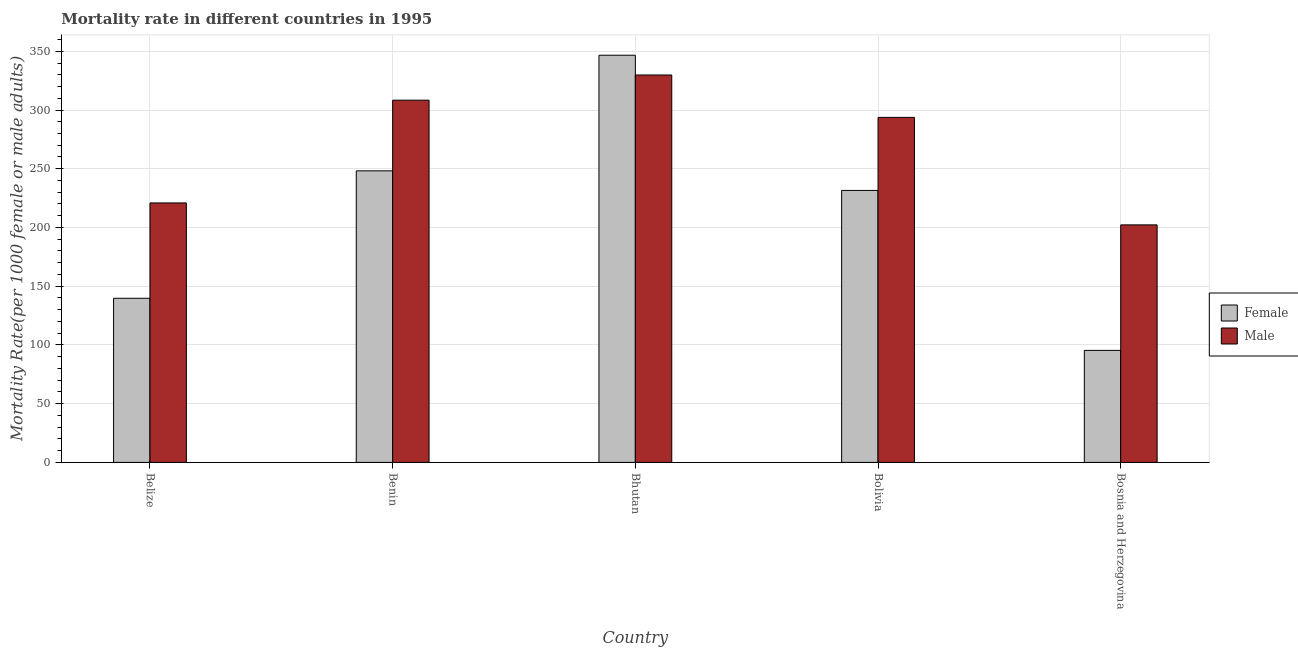How many different coloured bars are there?
Your answer should be compact. 2. Are the number of bars per tick equal to the number of legend labels?
Provide a succinct answer. Yes. Are the number of bars on each tick of the X-axis equal?
Your response must be concise. Yes. What is the label of the 1st group of bars from the left?
Your answer should be compact. Belize. In how many cases, is the number of bars for a given country not equal to the number of legend labels?
Offer a very short reply. 0. What is the male mortality rate in Bolivia?
Offer a terse response. 293.72. Across all countries, what is the maximum male mortality rate?
Keep it short and to the point. 329.81. Across all countries, what is the minimum male mortality rate?
Make the answer very short. 202.21. In which country was the male mortality rate maximum?
Your answer should be compact. Bhutan. In which country was the male mortality rate minimum?
Your response must be concise. Bosnia and Herzegovina. What is the total female mortality rate in the graph?
Offer a very short reply. 1061.44. What is the difference between the male mortality rate in Benin and that in Bhutan?
Keep it short and to the point. -21.44. What is the difference between the female mortality rate in Benin and the male mortality rate in Bhutan?
Give a very brief answer. -81.6. What is the average female mortality rate per country?
Give a very brief answer. 212.29. What is the difference between the male mortality rate and female mortality rate in Bosnia and Herzegovina?
Provide a short and direct response. 106.85. What is the ratio of the male mortality rate in Benin to that in Bolivia?
Your response must be concise. 1.05. Is the female mortality rate in Belize less than that in Bosnia and Herzegovina?
Your response must be concise. No. What is the difference between the highest and the second highest male mortality rate?
Keep it short and to the point. 21.44. What is the difference between the highest and the lowest male mortality rate?
Make the answer very short. 127.6. What does the 1st bar from the left in Benin represents?
Give a very brief answer. Female. What does the 1st bar from the right in Belize represents?
Your answer should be very brief. Male. Are all the bars in the graph horizontal?
Provide a short and direct response. No. What is the difference between two consecutive major ticks on the Y-axis?
Your answer should be very brief. 50. Are the values on the major ticks of Y-axis written in scientific E-notation?
Give a very brief answer. No. Does the graph contain any zero values?
Your answer should be very brief. No. Where does the legend appear in the graph?
Make the answer very short. Center right. What is the title of the graph?
Your response must be concise. Mortality rate in different countries in 1995. What is the label or title of the X-axis?
Give a very brief answer. Country. What is the label or title of the Y-axis?
Provide a succinct answer. Mortality Rate(per 1000 female or male adults). What is the Mortality Rate(per 1000 female or male adults) in Female in Belize?
Your answer should be compact. 139.72. What is the Mortality Rate(per 1000 female or male adults) of Male in Belize?
Provide a short and direct response. 220.89. What is the Mortality Rate(per 1000 female or male adults) in Female in Benin?
Your response must be concise. 248.21. What is the Mortality Rate(per 1000 female or male adults) of Male in Benin?
Offer a very short reply. 308.37. What is the Mortality Rate(per 1000 female or male adults) of Female in Bhutan?
Provide a short and direct response. 346.63. What is the Mortality Rate(per 1000 female or male adults) of Male in Bhutan?
Offer a terse response. 329.81. What is the Mortality Rate(per 1000 female or male adults) of Female in Bolivia?
Provide a short and direct response. 231.53. What is the Mortality Rate(per 1000 female or male adults) in Male in Bolivia?
Keep it short and to the point. 293.72. What is the Mortality Rate(per 1000 female or male adults) in Female in Bosnia and Herzegovina?
Your answer should be very brief. 95.36. What is the Mortality Rate(per 1000 female or male adults) in Male in Bosnia and Herzegovina?
Keep it short and to the point. 202.21. Across all countries, what is the maximum Mortality Rate(per 1000 female or male adults) of Female?
Your response must be concise. 346.63. Across all countries, what is the maximum Mortality Rate(per 1000 female or male adults) of Male?
Offer a very short reply. 329.81. Across all countries, what is the minimum Mortality Rate(per 1000 female or male adults) in Female?
Your answer should be compact. 95.36. Across all countries, what is the minimum Mortality Rate(per 1000 female or male adults) in Male?
Make the answer very short. 202.21. What is the total Mortality Rate(per 1000 female or male adults) of Female in the graph?
Your answer should be compact. 1061.44. What is the total Mortality Rate(per 1000 female or male adults) in Male in the graph?
Provide a short and direct response. 1355. What is the difference between the Mortality Rate(per 1000 female or male adults) of Female in Belize and that in Benin?
Your answer should be compact. -108.49. What is the difference between the Mortality Rate(per 1000 female or male adults) of Male in Belize and that in Benin?
Ensure brevity in your answer.  -87.48. What is the difference between the Mortality Rate(per 1000 female or male adults) of Female in Belize and that in Bhutan?
Ensure brevity in your answer.  -206.91. What is the difference between the Mortality Rate(per 1000 female or male adults) in Male in Belize and that in Bhutan?
Your answer should be compact. -108.92. What is the difference between the Mortality Rate(per 1000 female or male adults) of Female in Belize and that in Bolivia?
Your answer should be very brief. -91.81. What is the difference between the Mortality Rate(per 1000 female or male adults) of Male in Belize and that in Bolivia?
Your answer should be compact. -72.83. What is the difference between the Mortality Rate(per 1000 female or male adults) in Female in Belize and that in Bosnia and Herzegovina?
Make the answer very short. 44.36. What is the difference between the Mortality Rate(per 1000 female or male adults) of Male in Belize and that in Bosnia and Herzegovina?
Make the answer very short. 18.68. What is the difference between the Mortality Rate(per 1000 female or male adults) of Female in Benin and that in Bhutan?
Make the answer very short. -98.42. What is the difference between the Mortality Rate(per 1000 female or male adults) in Male in Benin and that in Bhutan?
Your answer should be very brief. -21.44. What is the difference between the Mortality Rate(per 1000 female or male adults) in Female in Benin and that in Bolivia?
Keep it short and to the point. 16.67. What is the difference between the Mortality Rate(per 1000 female or male adults) in Male in Benin and that in Bolivia?
Keep it short and to the point. 14.65. What is the difference between the Mortality Rate(per 1000 female or male adults) in Female in Benin and that in Bosnia and Herzegovina?
Provide a short and direct response. 152.85. What is the difference between the Mortality Rate(per 1000 female or male adults) of Male in Benin and that in Bosnia and Herzegovina?
Offer a very short reply. 106.17. What is the difference between the Mortality Rate(per 1000 female or male adults) in Female in Bhutan and that in Bolivia?
Provide a succinct answer. 115.1. What is the difference between the Mortality Rate(per 1000 female or male adults) in Male in Bhutan and that in Bolivia?
Offer a very short reply. 36.09. What is the difference between the Mortality Rate(per 1000 female or male adults) in Female in Bhutan and that in Bosnia and Herzegovina?
Provide a short and direct response. 251.27. What is the difference between the Mortality Rate(per 1000 female or male adults) of Male in Bhutan and that in Bosnia and Herzegovina?
Provide a succinct answer. 127.6. What is the difference between the Mortality Rate(per 1000 female or male adults) in Female in Bolivia and that in Bosnia and Herzegovina?
Your answer should be very brief. 136.18. What is the difference between the Mortality Rate(per 1000 female or male adults) in Male in Bolivia and that in Bosnia and Herzegovina?
Make the answer very short. 91.52. What is the difference between the Mortality Rate(per 1000 female or male adults) in Female in Belize and the Mortality Rate(per 1000 female or male adults) in Male in Benin?
Give a very brief answer. -168.65. What is the difference between the Mortality Rate(per 1000 female or male adults) of Female in Belize and the Mortality Rate(per 1000 female or male adults) of Male in Bhutan?
Keep it short and to the point. -190.09. What is the difference between the Mortality Rate(per 1000 female or male adults) of Female in Belize and the Mortality Rate(per 1000 female or male adults) of Male in Bolivia?
Your response must be concise. -154. What is the difference between the Mortality Rate(per 1000 female or male adults) in Female in Belize and the Mortality Rate(per 1000 female or male adults) in Male in Bosnia and Herzegovina?
Provide a short and direct response. -62.49. What is the difference between the Mortality Rate(per 1000 female or male adults) in Female in Benin and the Mortality Rate(per 1000 female or male adults) in Male in Bhutan?
Provide a succinct answer. -81.61. What is the difference between the Mortality Rate(per 1000 female or male adults) of Female in Benin and the Mortality Rate(per 1000 female or male adults) of Male in Bolivia?
Ensure brevity in your answer.  -45.52. What is the difference between the Mortality Rate(per 1000 female or male adults) of Female in Benin and the Mortality Rate(per 1000 female or male adults) of Male in Bosnia and Herzegovina?
Give a very brief answer. 46. What is the difference between the Mortality Rate(per 1000 female or male adults) of Female in Bhutan and the Mortality Rate(per 1000 female or male adults) of Male in Bolivia?
Provide a short and direct response. 52.91. What is the difference between the Mortality Rate(per 1000 female or male adults) in Female in Bhutan and the Mortality Rate(per 1000 female or male adults) in Male in Bosnia and Herzegovina?
Give a very brief answer. 144.42. What is the difference between the Mortality Rate(per 1000 female or male adults) in Female in Bolivia and the Mortality Rate(per 1000 female or male adults) in Male in Bosnia and Herzegovina?
Your answer should be compact. 29.33. What is the average Mortality Rate(per 1000 female or male adults) in Female per country?
Offer a terse response. 212.29. What is the average Mortality Rate(per 1000 female or male adults) of Male per country?
Ensure brevity in your answer.  271. What is the difference between the Mortality Rate(per 1000 female or male adults) of Female and Mortality Rate(per 1000 female or male adults) of Male in Belize?
Provide a short and direct response. -81.17. What is the difference between the Mortality Rate(per 1000 female or male adults) of Female and Mortality Rate(per 1000 female or male adults) of Male in Benin?
Provide a short and direct response. -60.17. What is the difference between the Mortality Rate(per 1000 female or male adults) of Female and Mortality Rate(per 1000 female or male adults) of Male in Bhutan?
Your answer should be compact. 16.82. What is the difference between the Mortality Rate(per 1000 female or male adults) in Female and Mortality Rate(per 1000 female or male adults) in Male in Bolivia?
Provide a short and direct response. -62.19. What is the difference between the Mortality Rate(per 1000 female or male adults) of Female and Mortality Rate(per 1000 female or male adults) of Male in Bosnia and Herzegovina?
Make the answer very short. -106.85. What is the ratio of the Mortality Rate(per 1000 female or male adults) in Female in Belize to that in Benin?
Offer a very short reply. 0.56. What is the ratio of the Mortality Rate(per 1000 female or male adults) of Male in Belize to that in Benin?
Provide a succinct answer. 0.72. What is the ratio of the Mortality Rate(per 1000 female or male adults) of Female in Belize to that in Bhutan?
Your answer should be very brief. 0.4. What is the ratio of the Mortality Rate(per 1000 female or male adults) in Male in Belize to that in Bhutan?
Give a very brief answer. 0.67. What is the ratio of the Mortality Rate(per 1000 female or male adults) in Female in Belize to that in Bolivia?
Offer a terse response. 0.6. What is the ratio of the Mortality Rate(per 1000 female or male adults) of Male in Belize to that in Bolivia?
Make the answer very short. 0.75. What is the ratio of the Mortality Rate(per 1000 female or male adults) in Female in Belize to that in Bosnia and Herzegovina?
Your answer should be compact. 1.47. What is the ratio of the Mortality Rate(per 1000 female or male adults) of Male in Belize to that in Bosnia and Herzegovina?
Provide a succinct answer. 1.09. What is the ratio of the Mortality Rate(per 1000 female or male adults) of Female in Benin to that in Bhutan?
Your answer should be very brief. 0.72. What is the ratio of the Mortality Rate(per 1000 female or male adults) of Male in Benin to that in Bhutan?
Your answer should be very brief. 0.94. What is the ratio of the Mortality Rate(per 1000 female or male adults) in Female in Benin to that in Bolivia?
Keep it short and to the point. 1.07. What is the ratio of the Mortality Rate(per 1000 female or male adults) of Male in Benin to that in Bolivia?
Provide a short and direct response. 1.05. What is the ratio of the Mortality Rate(per 1000 female or male adults) in Female in Benin to that in Bosnia and Herzegovina?
Give a very brief answer. 2.6. What is the ratio of the Mortality Rate(per 1000 female or male adults) of Male in Benin to that in Bosnia and Herzegovina?
Ensure brevity in your answer.  1.52. What is the ratio of the Mortality Rate(per 1000 female or male adults) of Female in Bhutan to that in Bolivia?
Your response must be concise. 1.5. What is the ratio of the Mortality Rate(per 1000 female or male adults) of Male in Bhutan to that in Bolivia?
Make the answer very short. 1.12. What is the ratio of the Mortality Rate(per 1000 female or male adults) in Female in Bhutan to that in Bosnia and Herzegovina?
Offer a very short reply. 3.64. What is the ratio of the Mortality Rate(per 1000 female or male adults) of Male in Bhutan to that in Bosnia and Herzegovina?
Your answer should be very brief. 1.63. What is the ratio of the Mortality Rate(per 1000 female or male adults) of Female in Bolivia to that in Bosnia and Herzegovina?
Offer a terse response. 2.43. What is the ratio of the Mortality Rate(per 1000 female or male adults) in Male in Bolivia to that in Bosnia and Herzegovina?
Keep it short and to the point. 1.45. What is the difference between the highest and the second highest Mortality Rate(per 1000 female or male adults) of Female?
Offer a terse response. 98.42. What is the difference between the highest and the second highest Mortality Rate(per 1000 female or male adults) of Male?
Make the answer very short. 21.44. What is the difference between the highest and the lowest Mortality Rate(per 1000 female or male adults) in Female?
Offer a very short reply. 251.27. What is the difference between the highest and the lowest Mortality Rate(per 1000 female or male adults) of Male?
Make the answer very short. 127.6. 